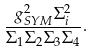<formula> <loc_0><loc_0><loc_500><loc_500>\frac { g _ { S Y M } ^ { 2 } \Sigma _ { i } ^ { 2 } } { \Sigma _ { 1 } \Sigma _ { 2 } \Sigma _ { 3 } \Sigma _ { 4 } } .</formula> 